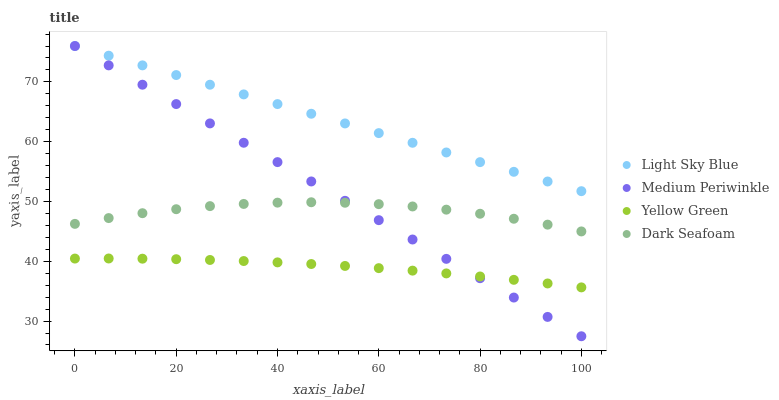Does Yellow Green have the minimum area under the curve?
Answer yes or no. Yes. Does Light Sky Blue have the maximum area under the curve?
Answer yes or no. Yes. Does Medium Periwinkle have the minimum area under the curve?
Answer yes or no. No. Does Medium Periwinkle have the maximum area under the curve?
Answer yes or no. No. Is Medium Periwinkle the smoothest?
Answer yes or no. Yes. Is Dark Seafoam the roughest?
Answer yes or no. Yes. Is Light Sky Blue the smoothest?
Answer yes or no. No. Is Light Sky Blue the roughest?
Answer yes or no. No. Does Medium Periwinkle have the lowest value?
Answer yes or no. Yes. Does Light Sky Blue have the lowest value?
Answer yes or no. No. Does Medium Periwinkle have the highest value?
Answer yes or no. Yes. Does Yellow Green have the highest value?
Answer yes or no. No. Is Yellow Green less than Dark Seafoam?
Answer yes or no. Yes. Is Light Sky Blue greater than Dark Seafoam?
Answer yes or no. Yes. Does Medium Periwinkle intersect Dark Seafoam?
Answer yes or no. Yes. Is Medium Periwinkle less than Dark Seafoam?
Answer yes or no. No. Is Medium Periwinkle greater than Dark Seafoam?
Answer yes or no. No. Does Yellow Green intersect Dark Seafoam?
Answer yes or no. No. 